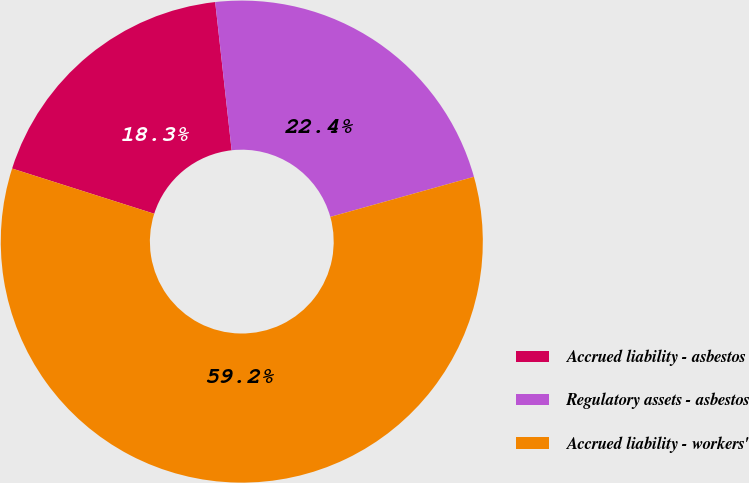Convert chart to OTSL. <chart><loc_0><loc_0><loc_500><loc_500><pie_chart><fcel>Accrued liability - asbestos<fcel>Regulatory assets - asbestos<fcel>Accrued liability - workers'<nl><fcel>18.34%<fcel>22.43%<fcel>59.24%<nl></chart> 